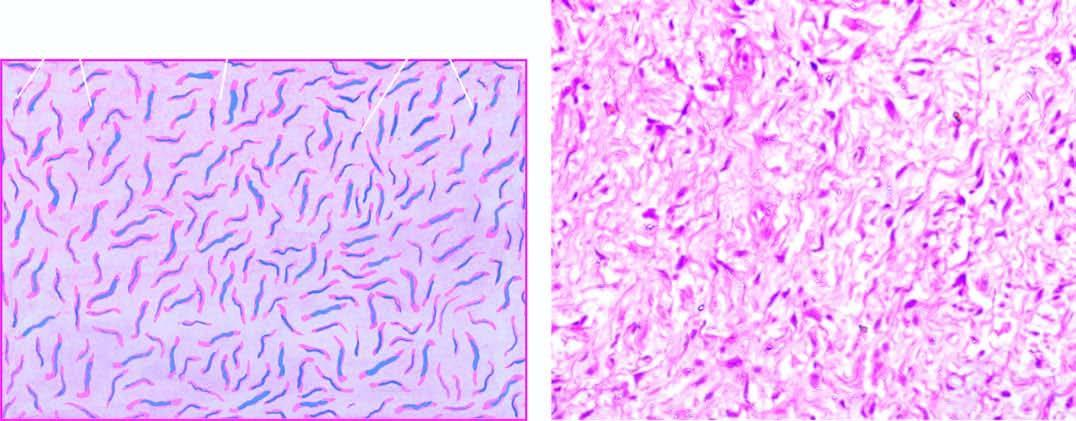do individual myocardial fibres have wavy nuclei?
Answer the question using a single word or phrase. No 